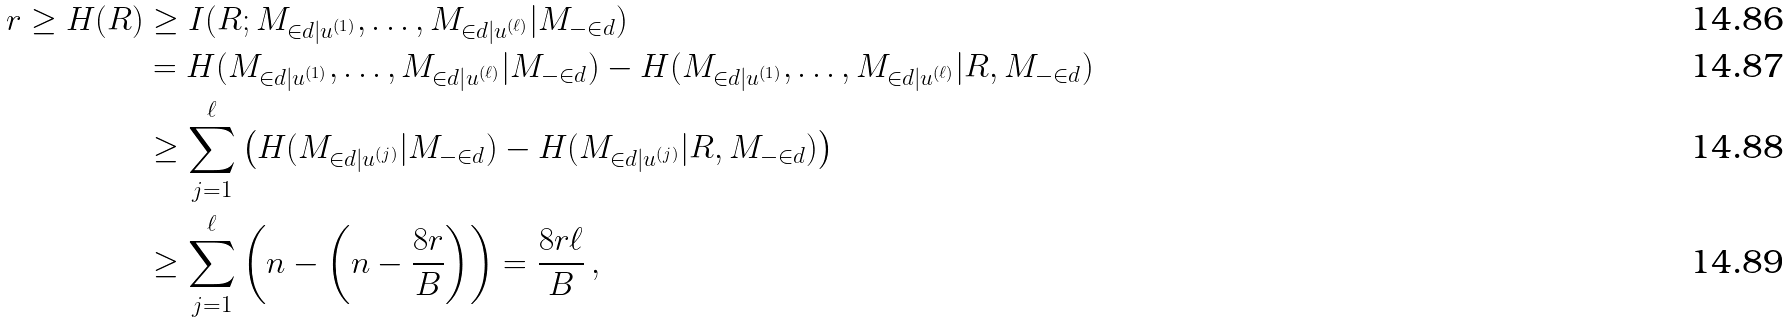<formula> <loc_0><loc_0><loc_500><loc_500>r \geq H ( R ) & \geq I ( R ; M _ { \in d | u ^ { ( 1 ) } } , \dots , M _ { \in d | u ^ { ( \ell ) } } | M _ { - \in d } ) \\ & = H ( M _ { \in d | u ^ { ( 1 ) } } , \dots , M _ { \in d | u ^ { ( \ell ) } } | M _ { - \in d } ) - H ( M _ { \in d | u ^ { ( 1 ) } } , \dots , M _ { \in d | u ^ { ( \ell ) } } | R , M _ { - \in d } ) \\ & \geq \sum _ { j = 1 } ^ { \ell } { \left ( H ( M _ { \in d | u ^ { ( j ) } } | M _ { - \in d } ) - H ( M _ { \in d | u ^ { ( j ) } } | R , M _ { - \in d } ) \right ) } \\ & \geq \sum _ { j = 1 } ^ { \ell } { \left ( n - \left ( n - \frac { 8 r } { B } \right ) \right ) } = \frac { 8 r \ell } { B } \, ,</formula> 